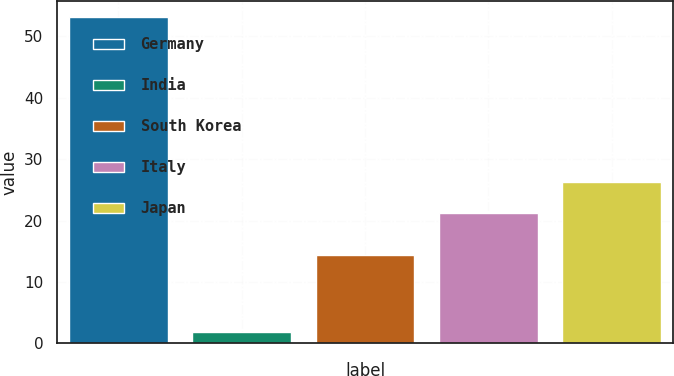<chart> <loc_0><loc_0><loc_500><loc_500><bar_chart><fcel>Germany<fcel>India<fcel>South Korea<fcel>Italy<fcel>Japan<nl><fcel>53.1<fcel>1.8<fcel>14.4<fcel>21.2<fcel>26.33<nl></chart> 